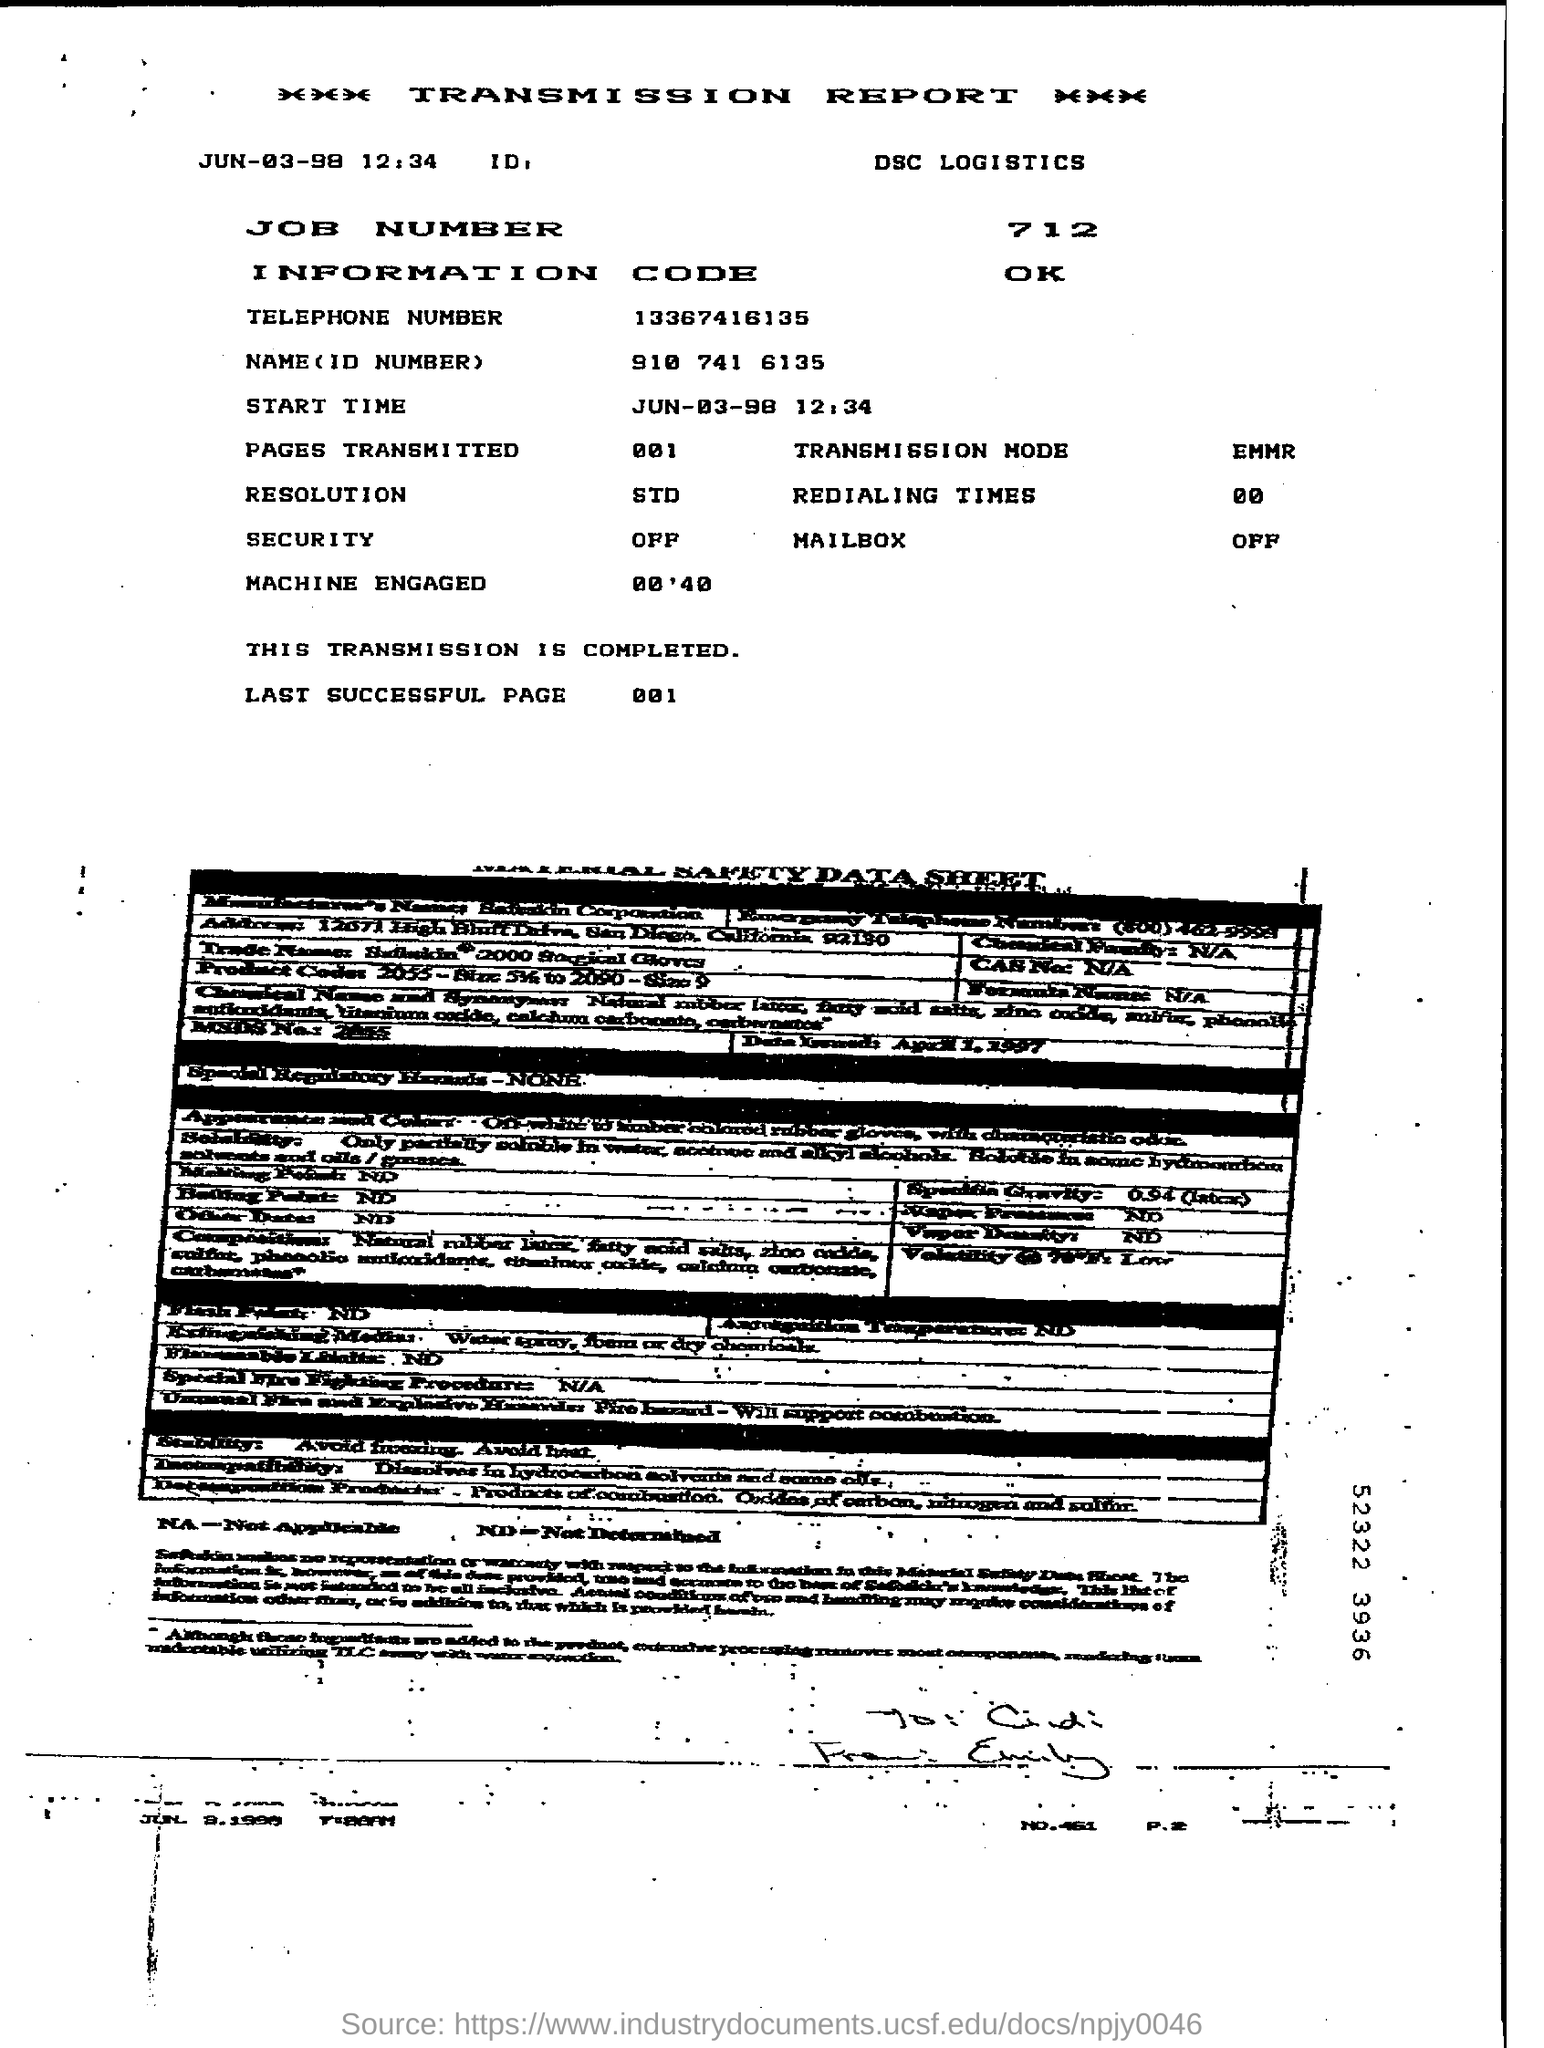What is the start time mentioned?
Provide a short and direct response. 12:34. What is the job number?
Offer a very short reply. 712. What is the information code mentioned?
Offer a terse response. OK. What is transmission mode?
Offer a very short reply. EMMR. 